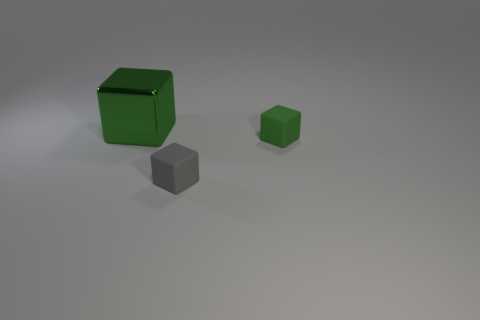Is there anything else that has the same material as the large green block?
Provide a succinct answer. No. There is a green matte thing; is its shape the same as the thing that is on the left side of the gray matte object?
Your response must be concise. Yes. Is there a green thing?
Your answer should be very brief. Yes. What number of tiny things are yellow rubber objects or green matte things?
Provide a succinct answer. 1. Are there more tiny gray cubes that are in front of the tiny green thing than gray rubber cubes that are on the left side of the green metallic cube?
Give a very brief answer. Yes. Does the tiny gray cube have the same material as the green cube in front of the green shiny thing?
Your response must be concise. Yes. The green thing to the right of the green metal object has what shape?
Give a very brief answer. Cube. What number of cyan objects are tiny matte things or big shiny things?
Your answer should be compact. 0. What is the color of the other thing that is the same material as the tiny gray object?
Offer a terse response. Green. There is a metallic object; does it have the same color as the small object behind the gray matte object?
Your response must be concise. Yes. 